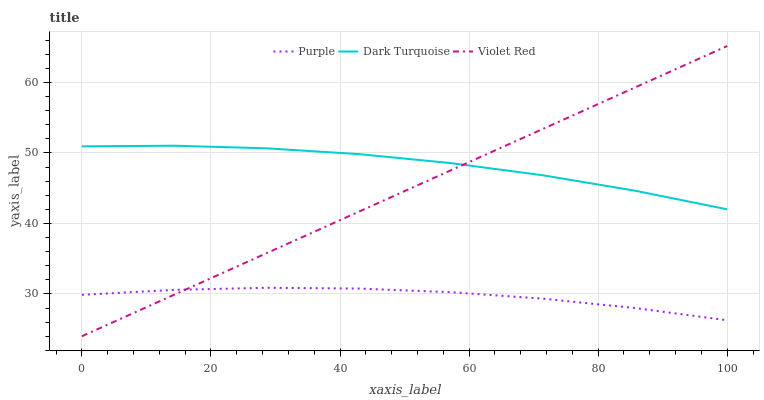Does Purple have the minimum area under the curve?
Answer yes or no. Yes. Does Dark Turquoise have the maximum area under the curve?
Answer yes or no. Yes. Does Violet Red have the minimum area under the curve?
Answer yes or no. No. Does Violet Red have the maximum area under the curve?
Answer yes or no. No. Is Violet Red the smoothest?
Answer yes or no. Yes. Is Dark Turquoise the roughest?
Answer yes or no. Yes. Is Dark Turquoise the smoothest?
Answer yes or no. No. Is Violet Red the roughest?
Answer yes or no. No. Does Violet Red have the lowest value?
Answer yes or no. Yes. Does Dark Turquoise have the lowest value?
Answer yes or no. No. Does Violet Red have the highest value?
Answer yes or no. Yes. Does Dark Turquoise have the highest value?
Answer yes or no. No. Is Purple less than Dark Turquoise?
Answer yes or no. Yes. Is Dark Turquoise greater than Purple?
Answer yes or no. Yes. Does Violet Red intersect Dark Turquoise?
Answer yes or no. Yes. Is Violet Red less than Dark Turquoise?
Answer yes or no. No. Is Violet Red greater than Dark Turquoise?
Answer yes or no. No. Does Purple intersect Dark Turquoise?
Answer yes or no. No. 